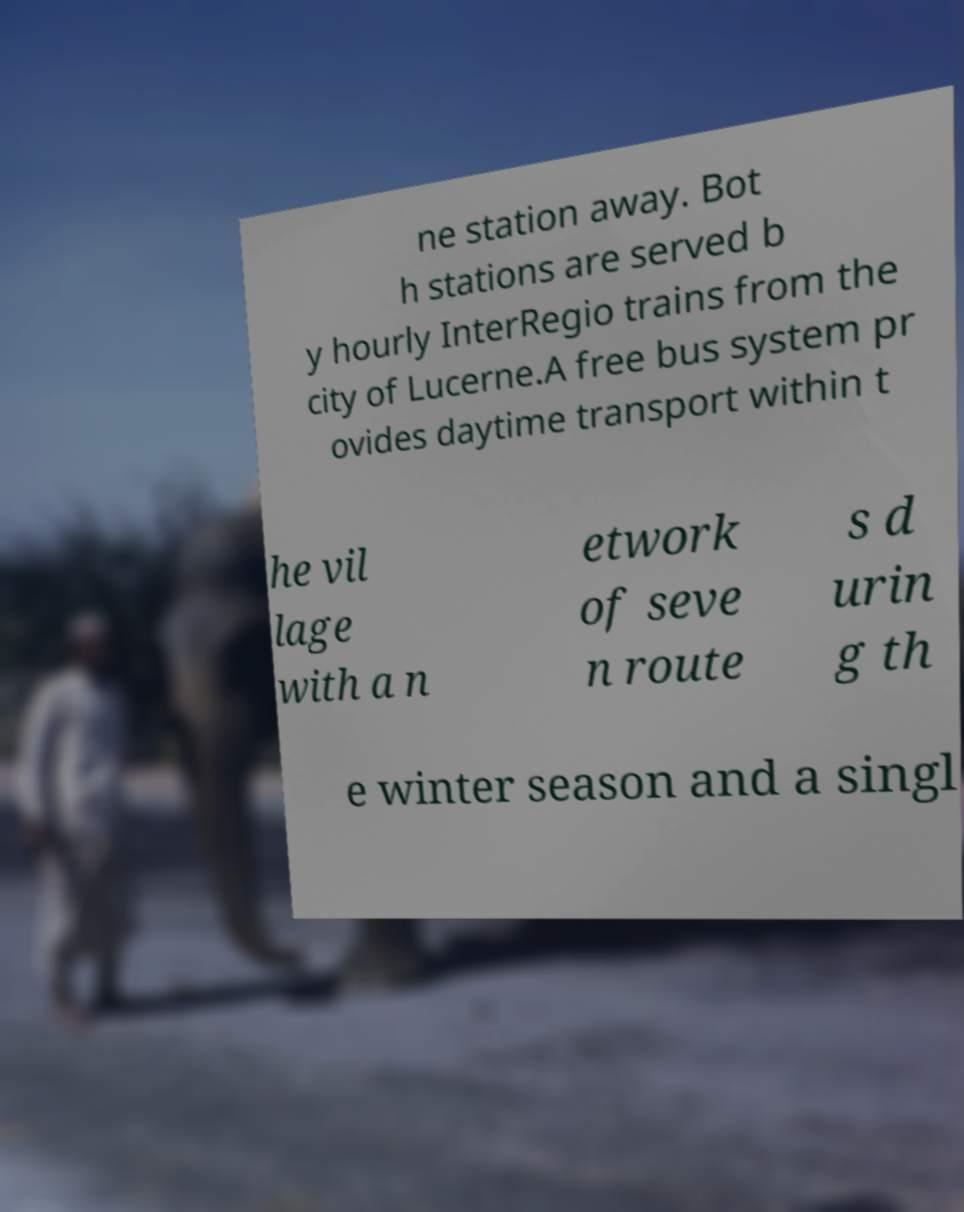Please read and relay the text visible in this image. What does it say? ne station away. Bot h stations are served b y hourly InterRegio trains from the city of Lucerne.A free bus system pr ovides daytime transport within t he vil lage with a n etwork of seve n route s d urin g th e winter season and a singl 